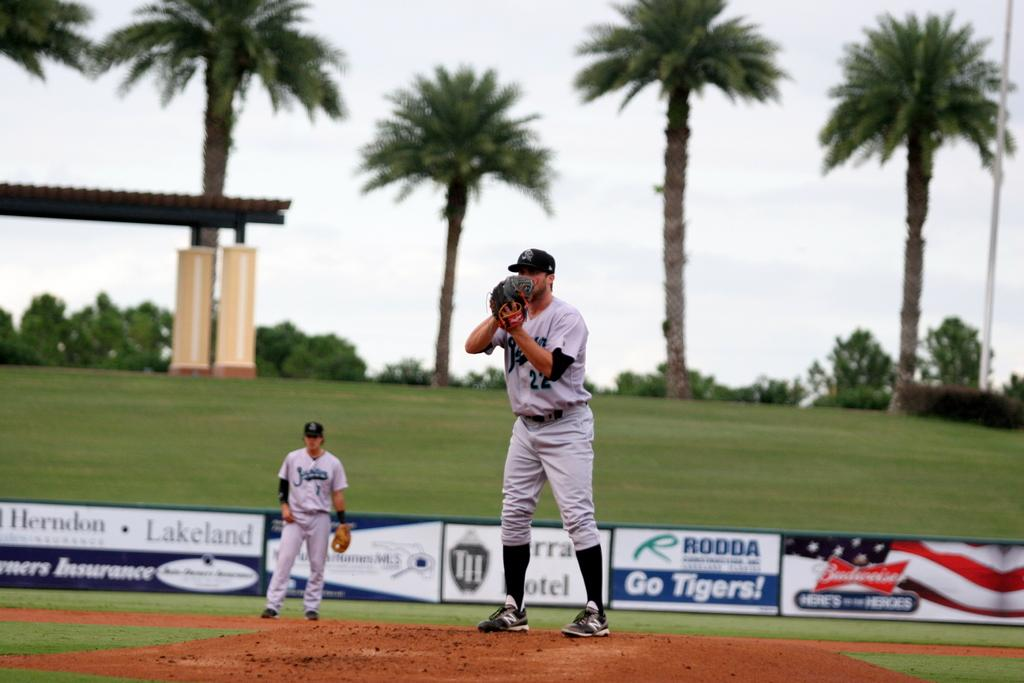<image>
Summarize the visual content of the image. Budweiser advertises at the Tigers minor league stadium. 